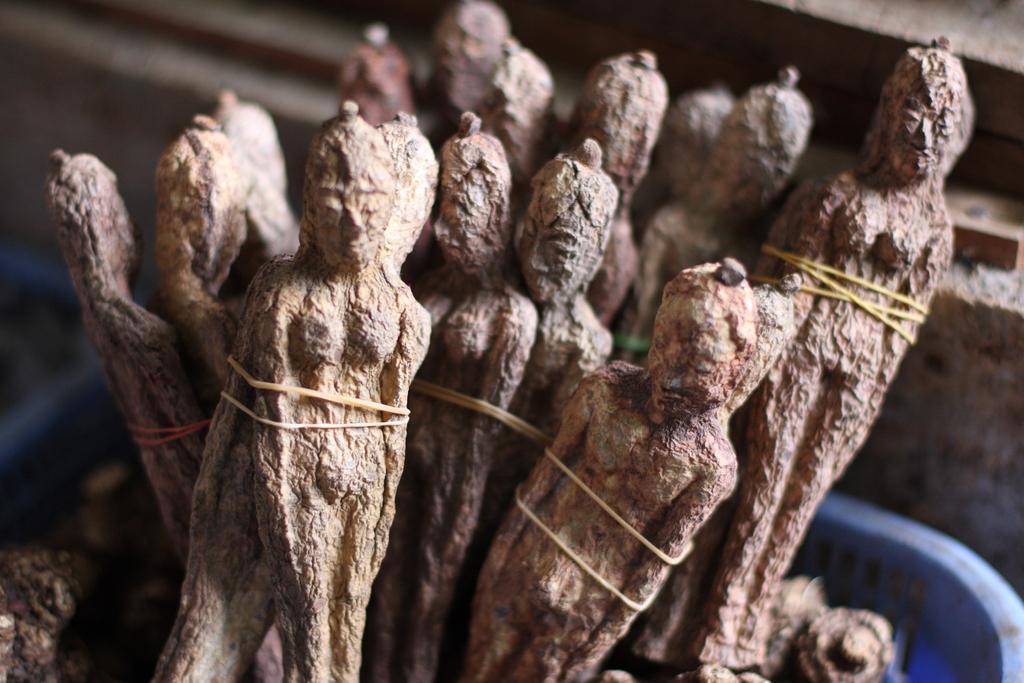Could you give a brief overview of what you see in this image? In this image there are sculptures in a tray, in the background it is blurred. 